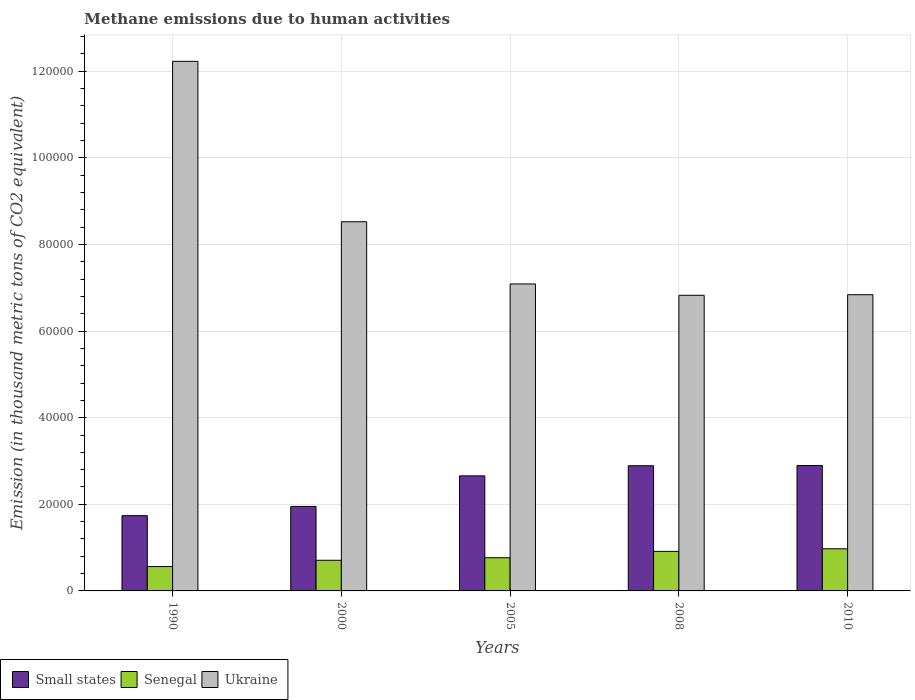Are the number of bars per tick equal to the number of legend labels?
Your response must be concise. Yes. Are the number of bars on each tick of the X-axis equal?
Keep it short and to the point. Yes. What is the label of the 2nd group of bars from the left?
Give a very brief answer. 2000. In how many cases, is the number of bars for a given year not equal to the number of legend labels?
Your answer should be very brief. 0. What is the amount of methane emitted in Ukraine in 2010?
Ensure brevity in your answer.  6.84e+04. Across all years, what is the maximum amount of methane emitted in Ukraine?
Ensure brevity in your answer.  1.22e+05. Across all years, what is the minimum amount of methane emitted in Ukraine?
Make the answer very short. 6.83e+04. What is the total amount of methane emitted in Senegal in the graph?
Give a very brief answer. 3.92e+04. What is the difference between the amount of methane emitted in Senegal in 1990 and that in 2000?
Your response must be concise. -1449.9. What is the difference between the amount of methane emitted in Small states in 2000 and the amount of methane emitted in Ukraine in 2010?
Make the answer very short. -4.89e+04. What is the average amount of methane emitted in Small states per year?
Offer a very short reply. 2.43e+04. In the year 2010, what is the difference between the amount of methane emitted in Ukraine and amount of methane emitted in Senegal?
Your response must be concise. 5.87e+04. In how many years, is the amount of methane emitted in Senegal greater than 88000 thousand metric tons?
Provide a short and direct response. 0. What is the ratio of the amount of methane emitted in Ukraine in 1990 to that in 2000?
Your response must be concise. 1.43. Is the amount of methane emitted in Ukraine in 1990 less than that in 2008?
Ensure brevity in your answer.  No. What is the difference between the highest and the second highest amount of methane emitted in Ukraine?
Make the answer very short. 3.70e+04. What is the difference between the highest and the lowest amount of methane emitted in Ukraine?
Your answer should be compact. 5.40e+04. What does the 1st bar from the left in 2005 represents?
Make the answer very short. Small states. What does the 3rd bar from the right in 1990 represents?
Offer a terse response. Small states. How many bars are there?
Keep it short and to the point. 15. Does the graph contain any zero values?
Offer a very short reply. No. Does the graph contain grids?
Your response must be concise. Yes. Where does the legend appear in the graph?
Ensure brevity in your answer.  Bottom left. How many legend labels are there?
Keep it short and to the point. 3. What is the title of the graph?
Provide a short and direct response. Methane emissions due to human activities. Does "Turkmenistan" appear as one of the legend labels in the graph?
Offer a very short reply. No. What is the label or title of the Y-axis?
Ensure brevity in your answer.  Emission (in thousand metric tons of CO2 equivalent). What is the Emission (in thousand metric tons of CO2 equivalent) in Small states in 1990?
Offer a very short reply. 1.74e+04. What is the Emission (in thousand metric tons of CO2 equivalent) of Senegal in 1990?
Provide a succinct answer. 5628.2. What is the Emission (in thousand metric tons of CO2 equivalent) in Ukraine in 1990?
Make the answer very short. 1.22e+05. What is the Emission (in thousand metric tons of CO2 equivalent) in Small states in 2000?
Make the answer very short. 1.95e+04. What is the Emission (in thousand metric tons of CO2 equivalent) of Senegal in 2000?
Keep it short and to the point. 7078.1. What is the Emission (in thousand metric tons of CO2 equivalent) of Ukraine in 2000?
Your response must be concise. 8.52e+04. What is the Emission (in thousand metric tons of CO2 equivalent) in Small states in 2005?
Provide a short and direct response. 2.66e+04. What is the Emission (in thousand metric tons of CO2 equivalent) of Senegal in 2005?
Provide a succinct answer. 7662.4. What is the Emission (in thousand metric tons of CO2 equivalent) of Ukraine in 2005?
Provide a short and direct response. 7.09e+04. What is the Emission (in thousand metric tons of CO2 equivalent) of Small states in 2008?
Offer a terse response. 2.89e+04. What is the Emission (in thousand metric tons of CO2 equivalent) of Senegal in 2008?
Provide a succinct answer. 9131.9. What is the Emission (in thousand metric tons of CO2 equivalent) of Ukraine in 2008?
Your response must be concise. 6.83e+04. What is the Emission (in thousand metric tons of CO2 equivalent) of Small states in 2010?
Your response must be concise. 2.90e+04. What is the Emission (in thousand metric tons of CO2 equivalent) in Senegal in 2010?
Give a very brief answer. 9732.9. What is the Emission (in thousand metric tons of CO2 equivalent) in Ukraine in 2010?
Keep it short and to the point. 6.84e+04. Across all years, what is the maximum Emission (in thousand metric tons of CO2 equivalent) of Small states?
Your response must be concise. 2.90e+04. Across all years, what is the maximum Emission (in thousand metric tons of CO2 equivalent) of Senegal?
Give a very brief answer. 9732.9. Across all years, what is the maximum Emission (in thousand metric tons of CO2 equivalent) in Ukraine?
Make the answer very short. 1.22e+05. Across all years, what is the minimum Emission (in thousand metric tons of CO2 equivalent) in Small states?
Provide a short and direct response. 1.74e+04. Across all years, what is the minimum Emission (in thousand metric tons of CO2 equivalent) of Senegal?
Provide a succinct answer. 5628.2. Across all years, what is the minimum Emission (in thousand metric tons of CO2 equivalent) in Ukraine?
Provide a succinct answer. 6.83e+04. What is the total Emission (in thousand metric tons of CO2 equivalent) in Small states in the graph?
Your answer should be compact. 1.21e+05. What is the total Emission (in thousand metric tons of CO2 equivalent) of Senegal in the graph?
Provide a succinct answer. 3.92e+04. What is the total Emission (in thousand metric tons of CO2 equivalent) of Ukraine in the graph?
Provide a succinct answer. 4.15e+05. What is the difference between the Emission (in thousand metric tons of CO2 equivalent) in Small states in 1990 and that in 2000?
Your response must be concise. -2132.9. What is the difference between the Emission (in thousand metric tons of CO2 equivalent) in Senegal in 1990 and that in 2000?
Provide a succinct answer. -1449.9. What is the difference between the Emission (in thousand metric tons of CO2 equivalent) in Ukraine in 1990 and that in 2000?
Keep it short and to the point. 3.70e+04. What is the difference between the Emission (in thousand metric tons of CO2 equivalent) of Small states in 1990 and that in 2005?
Your answer should be compact. -9189.8. What is the difference between the Emission (in thousand metric tons of CO2 equivalent) in Senegal in 1990 and that in 2005?
Give a very brief answer. -2034.2. What is the difference between the Emission (in thousand metric tons of CO2 equivalent) in Ukraine in 1990 and that in 2005?
Provide a short and direct response. 5.14e+04. What is the difference between the Emission (in thousand metric tons of CO2 equivalent) in Small states in 1990 and that in 2008?
Keep it short and to the point. -1.15e+04. What is the difference between the Emission (in thousand metric tons of CO2 equivalent) in Senegal in 1990 and that in 2008?
Your answer should be compact. -3503.7. What is the difference between the Emission (in thousand metric tons of CO2 equivalent) of Ukraine in 1990 and that in 2008?
Give a very brief answer. 5.40e+04. What is the difference between the Emission (in thousand metric tons of CO2 equivalent) of Small states in 1990 and that in 2010?
Keep it short and to the point. -1.16e+04. What is the difference between the Emission (in thousand metric tons of CO2 equivalent) of Senegal in 1990 and that in 2010?
Give a very brief answer. -4104.7. What is the difference between the Emission (in thousand metric tons of CO2 equivalent) in Ukraine in 1990 and that in 2010?
Keep it short and to the point. 5.39e+04. What is the difference between the Emission (in thousand metric tons of CO2 equivalent) in Small states in 2000 and that in 2005?
Offer a terse response. -7056.9. What is the difference between the Emission (in thousand metric tons of CO2 equivalent) of Senegal in 2000 and that in 2005?
Offer a very short reply. -584.3. What is the difference between the Emission (in thousand metric tons of CO2 equivalent) in Ukraine in 2000 and that in 2005?
Your answer should be compact. 1.44e+04. What is the difference between the Emission (in thousand metric tons of CO2 equivalent) of Small states in 2000 and that in 2008?
Your answer should be compact. -9393.1. What is the difference between the Emission (in thousand metric tons of CO2 equivalent) of Senegal in 2000 and that in 2008?
Your answer should be very brief. -2053.8. What is the difference between the Emission (in thousand metric tons of CO2 equivalent) in Ukraine in 2000 and that in 2008?
Ensure brevity in your answer.  1.70e+04. What is the difference between the Emission (in thousand metric tons of CO2 equivalent) in Small states in 2000 and that in 2010?
Your answer should be very brief. -9444.8. What is the difference between the Emission (in thousand metric tons of CO2 equivalent) of Senegal in 2000 and that in 2010?
Provide a succinct answer. -2654.8. What is the difference between the Emission (in thousand metric tons of CO2 equivalent) of Ukraine in 2000 and that in 2010?
Keep it short and to the point. 1.68e+04. What is the difference between the Emission (in thousand metric tons of CO2 equivalent) of Small states in 2005 and that in 2008?
Your answer should be compact. -2336.2. What is the difference between the Emission (in thousand metric tons of CO2 equivalent) in Senegal in 2005 and that in 2008?
Give a very brief answer. -1469.5. What is the difference between the Emission (in thousand metric tons of CO2 equivalent) of Ukraine in 2005 and that in 2008?
Make the answer very short. 2618.6. What is the difference between the Emission (in thousand metric tons of CO2 equivalent) in Small states in 2005 and that in 2010?
Your answer should be compact. -2387.9. What is the difference between the Emission (in thousand metric tons of CO2 equivalent) in Senegal in 2005 and that in 2010?
Your response must be concise. -2070.5. What is the difference between the Emission (in thousand metric tons of CO2 equivalent) in Ukraine in 2005 and that in 2010?
Your answer should be compact. 2486.2. What is the difference between the Emission (in thousand metric tons of CO2 equivalent) in Small states in 2008 and that in 2010?
Provide a short and direct response. -51.7. What is the difference between the Emission (in thousand metric tons of CO2 equivalent) of Senegal in 2008 and that in 2010?
Give a very brief answer. -601. What is the difference between the Emission (in thousand metric tons of CO2 equivalent) of Ukraine in 2008 and that in 2010?
Ensure brevity in your answer.  -132.4. What is the difference between the Emission (in thousand metric tons of CO2 equivalent) in Small states in 1990 and the Emission (in thousand metric tons of CO2 equivalent) in Senegal in 2000?
Keep it short and to the point. 1.03e+04. What is the difference between the Emission (in thousand metric tons of CO2 equivalent) of Small states in 1990 and the Emission (in thousand metric tons of CO2 equivalent) of Ukraine in 2000?
Give a very brief answer. -6.79e+04. What is the difference between the Emission (in thousand metric tons of CO2 equivalent) of Senegal in 1990 and the Emission (in thousand metric tons of CO2 equivalent) of Ukraine in 2000?
Your response must be concise. -7.96e+04. What is the difference between the Emission (in thousand metric tons of CO2 equivalent) of Small states in 1990 and the Emission (in thousand metric tons of CO2 equivalent) of Senegal in 2005?
Provide a succinct answer. 9716.3. What is the difference between the Emission (in thousand metric tons of CO2 equivalent) in Small states in 1990 and the Emission (in thousand metric tons of CO2 equivalent) in Ukraine in 2005?
Keep it short and to the point. -5.35e+04. What is the difference between the Emission (in thousand metric tons of CO2 equivalent) of Senegal in 1990 and the Emission (in thousand metric tons of CO2 equivalent) of Ukraine in 2005?
Your response must be concise. -6.53e+04. What is the difference between the Emission (in thousand metric tons of CO2 equivalent) of Small states in 1990 and the Emission (in thousand metric tons of CO2 equivalent) of Senegal in 2008?
Offer a very short reply. 8246.8. What is the difference between the Emission (in thousand metric tons of CO2 equivalent) of Small states in 1990 and the Emission (in thousand metric tons of CO2 equivalent) of Ukraine in 2008?
Provide a succinct answer. -5.09e+04. What is the difference between the Emission (in thousand metric tons of CO2 equivalent) of Senegal in 1990 and the Emission (in thousand metric tons of CO2 equivalent) of Ukraine in 2008?
Provide a short and direct response. -6.26e+04. What is the difference between the Emission (in thousand metric tons of CO2 equivalent) of Small states in 1990 and the Emission (in thousand metric tons of CO2 equivalent) of Senegal in 2010?
Make the answer very short. 7645.8. What is the difference between the Emission (in thousand metric tons of CO2 equivalent) in Small states in 1990 and the Emission (in thousand metric tons of CO2 equivalent) in Ukraine in 2010?
Keep it short and to the point. -5.10e+04. What is the difference between the Emission (in thousand metric tons of CO2 equivalent) of Senegal in 1990 and the Emission (in thousand metric tons of CO2 equivalent) of Ukraine in 2010?
Make the answer very short. -6.28e+04. What is the difference between the Emission (in thousand metric tons of CO2 equivalent) in Small states in 2000 and the Emission (in thousand metric tons of CO2 equivalent) in Senegal in 2005?
Provide a short and direct response. 1.18e+04. What is the difference between the Emission (in thousand metric tons of CO2 equivalent) of Small states in 2000 and the Emission (in thousand metric tons of CO2 equivalent) of Ukraine in 2005?
Your response must be concise. -5.14e+04. What is the difference between the Emission (in thousand metric tons of CO2 equivalent) of Senegal in 2000 and the Emission (in thousand metric tons of CO2 equivalent) of Ukraine in 2005?
Provide a succinct answer. -6.38e+04. What is the difference between the Emission (in thousand metric tons of CO2 equivalent) in Small states in 2000 and the Emission (in thousand metric tons of CO2 equivalent) in Senegal in 2008?
Provide a short and direct response. 1.04e+04. What is the difference between the Emission (in thousand metric tons of CO2 equivalent) in Small states in 2000 and the Emission (in thousand metric tons of CO2 equivalent) in Ukraine in 2008?
Offer a terse response. -4.88e+04. What is the difference between the Emission (in thousand metric tons of CO2 equivalent) of Senegal in 2000 and the Emission (in thousand metric tons of CO2 equivalent) of Ukraine in 2008?
Make the answer very short. -6.12e+04. What is the difference between the Emission (in thousand metric tons of CO2 equivalent) in Small states in 2000 and the Emission (in thousand metric tons of CO2 equivalent) in Senegal in 2010?
Give a very brief answer. 9778.7. What is the difference between the Emission (in thousand metric tons of CO2 equivalent) of Small states in 2000 and the Emission (in thousand metric tons of CO2 equivalent) of Ukraine in 2010?
Keep it short and to the point. -4.89e+04. What is the difference between the Emission (in thousand metric tons of CO2 equivalent) in Senegal in 2000 and the Emission (in thousand metric tons of CO2 equivalent) in Ukraine in 2010?
Provide a succinct answer. -6.13e+04. What is the difference between the Emission (in thousand metric tons of CO2 equivalent) in Small states in 2005 and the Emission (in thousand metric tons of CO2 equivalent) in Senegal in 2008?
Your answer should be compact. 1.74e+04. What is the difference between the Emission (in thousand metric tons of CO2 equivalent) of Small states in 2005 and the Emission (in thousand metric tons of CO2 equivalent) of Ukraine in 2008?
Ensure brevity in your answer.  -4.17e+04. What is the difference between the Emission (in thousand metric tons of CO2 equivalent) of Senegal in 2005 and the Emission (in thousand metric tons of CO2 equivalent) of Ukraine in 2008?
Make the answer very short. -6.06e+04. What is the difference between the Emission (in thousand metric tons of CO2 equivalent) in Small states in 2005 and the Emission (in thousand metric tons of CO2 equivalent) in Senegal in 2010?
Your answer should be very brief. 1.68e+04. What is the difference between the Emission (in thousand metric tons of CO2 equivalent) in Small states in 2005 and the Emission (in thousand metric tons of CO2 equivalent) in Ukraine in 2010?
Offer a very short reply. -4.18e+04. What is the difference between the Emission (in thousand metric tons of CO2 equivalent) of Senegal in 2005 and the Emission (in thousand metric tons of CO2 equivalent) of Ukraine in 2010?
Keep it short and to the point. -6.07e+04. What is the difference between the Emission (in thousand metric tons of CO2 equivalent) in Small states in 2008 and the Emission (in thousand metric tons of CO2 equivalent) in Senegal in 2010?
Ensure brevity in your answer.  1.92e+04. What is the difference between the Emission (in thousand metric tons of CO2 equivalent) in Small states in 2008 and the Emission (in thousand metric tons of CO2 equivalent) in Ukraine in 2010?
Provide a short and direct response. -3.95e+04. What is the difference between the Emission (in thousand metric tons of CO2 equivalent) of Senegal in 2008 and the Emission (in thousand metric tons of CO2 equivalent) of Ukraine in 2010?
Ensure brevity in your answer.  -5.93e+04. What is the average Emission (in thousand metric tons of CO2 equivalent) in Small states per year?
Offer a very short reply. 2.43e+04. What is the average Emission (in thousand metric tons of CO2 equivalent) in Senegal per year?
Offer a very short reply. 7846.7. What is the average Emission (in thousand metric tons of CO2 equivalent) in Ukraine per year?
Ensure brevity in your answer.  8.30e+04. In the year 1990, what is the difference between the Emission (in thousand metric tons of CO2 equivalent) of Small states and Emission (in thousand metric tons of CO2 equivalent) of Senegal?
Your answer should be very brief. 1.18e+04. In the year 1990, what is the difference between the Emission (in thousand metric tons of CO2 equivalent) in Small states and Emission (in thousand metric tons of CO2 equivalent) in Ukraine?
Your response must be concise. -1.05e+05. In the year 1990, what is the difference between the Emission (in thousand metric tons of CO2 equivalent) of Senegal and Emission (in thousand metric tons of CO2 equivalent) of Ukraine?
Give a very brief answer. -1.17e+05. In the year 2000, what is the difference between the Emission (in thousand metric tons of CO2 equivalent) of Small states and Emission (in thousand metric tons of CO2 equivalent) of Senegal?
Offer a very short reply. 1.24e+04. In the year 2000, what is the difference between the Emission (in thousand metric tons of CO2 equivalent) of Small states and Emission (in thousand metric tons of CO2 equivalent) of Ukraine?
Ensure brevity in your answer.  -6.57e+04. In the year 2000, what is the difference between the Emission (in thousand metric tons of CO2 equivalent) of Senegal and Emission (in thousand metric tons of CO2 equivalent) of Ukraine?
Make the answer very short. -7.82e+04. In the year 2005, what is the difference between the Emission (in thousand metric tons of CO2 equivalent) of Small states and Emission (in thousand metric tons of CO2 equivalent) of Senegal?
Keep it short and to the point. 1.89e+04. In the year 2005, what is the difference between the Emission (in thousand metric tons of CO2 equivalent) in Small states and Emission (in thousand metric tons of CO2 equivalent) in Ukraine?
Ensure brevity in your answer.  -4.43e+04. In the year 2005, what is the difference between the Emission (in thousand metric tons of CO2 equivalent) in Senegal and Emission (in thousand metric tons of CO2 equivalent) in Ukraine?
Your answer should be compact. -6.32e+04. In the year 2008, what is the difference between the Emission (in thousand metric tons of CO2 equivalent) in Small states and Emission (in thousand metric tons of CO2 equivalent) in Senegal?
Provide a succinct answer. 1.98e+04. In the year 2008, what is the difference between the Emission (in thousand metric tons of CO2 equivalent) of Small states and Emission (in thousand metric tons of CO2 equivalent) of Ukraine?
Your answer should be compact. -3.94e+04. In the year 2008, what is the difference between the Emission (in thousand metric tons of CO2 equivalent) of Senegal and Emission (in thousand metric tons of CO2 equivalent) of Ukraine?
Give a very brief answer. -5.91e+04. In the year 2010, what is the difference between the Emission (in thousand metric tons of CO2 equivalent) of Small states and Emission (in thousand metric tons of CO2 equivalent) of Senegal?
Your answer should be very brief. 1.92e+04. In the year 2010, what is the difference between the Emission (in thousand metric tons of CO2 equivalent) of Small states and Emission (in thousand metric tons of CO2 equivalent) of Ukraine?
Provide a short and direct response. -3.94e+04. In the year 2010, what is the difference between the Emission (in thousand metric tons of CO2 equivalent) in Senegal and Emission (in thousand metric tons of CO2 equivalent) in Ukraine?
Your response must be concise. -5.87e+04. What is the ratio of the Emission (in thousand metric tons of CO2 equivalent) in Small states in 1990 to that in 2000?
Provide a short and direct response. 0.89. What is the ratio of the Emission (in thousand metric tons of CO2 equivalent) in Senegal in 1990 to that in 2000?
Ensure brevity in your answer.  0.8. What is the ratio of the Emission (in thousand metric tons of CO2 equivalent) in Ukraine in 1990 to that in 2000?
Your answer should be compact. 1.43. What is the ratio of the Emission (in thousand metric tons of CO2 equivalent) in Small states in 1990 to that in 2005?
Your response must be concise. 0.65. What is the ratio of the Emission (in thousand metric tons of CO2 equivalent) of Senegal in 1990 to that in 2005?
Your response must be concise. 0.73. What is the ratio of the Emission (in thousand metric tons of CO2 equivalent) of Ukraine in 1990 to that in 2005?
Give a very brief answer. 1.73. What is the ratio of the Emission (in thousand metric tons of CO2 equivalent) of Small states in 1990 to that in 2008?
Provide a short and direct response. 0.6. What is the ratio of the Emission (in thousand metric tons of CO2 equivalent) in Senegal in 1990 to that in 2008?
Offer a terse response. 0.62. What is the ratio of the Emission (in thousand metric tons of CO2 equivalent) in Ukraine in 1990 to that in 2008?
Provide a succinct answer. 1.79. What is the ratio of the Emission (in thousand metric tons of CO2 equivalent) in Small states in 1990 to that in 2010?
Your answer should be compact. 0.6. What is the ratio of the Emission (in thousand metric tons of CO2 equivalent) in Senegal in 1990 to that in 2010?
Keep it short and to the point. 0.58. What is the ratio of the Emission (in thousand metric tons of CO2 equivalent) in Ukraine in 1990 to that in 2010?
Give a very brief answer. 1.79. What is the ratio of the Emission (in thousand metric tons of CO2 equivalent) of Small states in 2000 to that in 2005?
Your answer should be compact. 0.73. What is the ratio of the Emission (in thousand metric tons of CO2 equivalent) of Senegal in 2000 to that in 2005?
Your response must be concise. 0.92. What is the ratio of the Emission (in thousand metric tons of CO2 equivalent) of Ukraine in 2000 to that in 2005?
Your answer should be very brief. 1.2. What is the ratio of the Emission (in thousand metric tons of CO2 equivalent) of Small states in 2000 to that in 2008?
Keep it short and to the point. 0.68. What is the ratio of the Emission (in thousand metric tons of CO2 equivalent) of Senegal in 2000 to that in 2008?
Ensure brevity in your answer.  0.78. What is the ratio of the Emission (in thousand metric tons of CO2 equivalent) of Ukraine in 2000 to that in 2008?
Your answer should be very brief. 1.25. What is the ratio of the Emission (in thousand metric tons of CO2 equivalent) of Small states in 2000 to that in 2010?
Your answer should be very brief. 0.67. What is the ratio of the Emission (in thousand metric tons of CO2 equivalent) in Senegal in 2000 to that in 2010?
Offer a terse response. 0.73. What is the ratio of the Emission (in thousand metric tons of CO2 equivalent) of Ukraine in 2000 to that in 2010?
Ensure brevity in your answer.  1.25. What is the ratio of the Emission (in thousand metric tons of CO2 equivalent) in Small states in 2005 to that in 2008?
Offer a very short reply. 0.92. What is the ratio of the Emission (in thousand metric tons of CO2 equivalent) in Senegal in 2005 to that in 2008?
Your response must be concise. 0.84. What is the ratio of the Emission (in thousand metric tons of CO2 equivalent) in Ukraine in 2005 to that in 2008?
Offer a terse response. 1.04. What is the ratio of the Emission (in thousand metric tons of CO2 equivalent) of Small states in 2005 to that in 2010?
Provide a short and direct response. 0.92. What is the ratio of the Emission (in thousand metric tons of CO2 equivalent) in Senegal in 2005 to that in 2010?
Make the answer very short. 0.79. What is the ratio of the Emission (in thousand metric tons of CO2 equivalent) of Ukraine in 2005 to that in 2010?
Make the answer very short. 1.04. What is the ratio of the Emission (in thousand metric tons of CO2 equivalent) of Small states in 2008 to that in 2010?
Offer a terse response. 1. What is the ratio of the Emission (in thousand metric tons of CO2 equivalent) in Senegal in 2008 to that in 2010?
Your answer should be compact. 0.94. What is the ratio of the Emission (in thousand metric tons of CO2 equivalent) in Ukraine in 2008 to that in 2010?
Give a very brief answer. 1. What is the difference between the highest and the second highest Emission (in thousand metric tons of CO2 equivalent) in Small states?
Your response must be concise. 51.7. What is the difference between the highest and the second highest Emission (in thousand metric tons of CO2 equivalent) of Senegal?
Provide a short and direct response. 601. What is the difference between the highest and the second highest Emission (in thousand metric tons of CO2 equivalent) in Ukraine?
Offer a terse response. 3.70e+04. What is the difference between the highest and the lowest Emission (in thousand metric tons of CO2 equivalent) of Small states?
Your response must be concise. 1.16e+04. What is the difference between the highest and the lowest Emission (in thousand metric tons of CO2 equivalent) of Senegal?
Offer a terse response. 4104.7. What is the difference between the highest and the lowest Emission (in thousand metric tons of CO2 equivalent) in Ukraine?
Offer a terse response. 5.40e+04. 